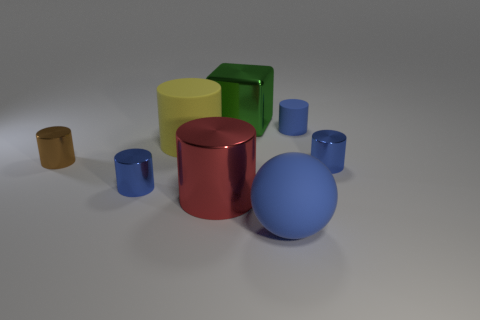How many blue cylinders must be subtracted to get 1 blue cylinders? 2 Subtract all big metal cylinders. How many cylinders are left? 5 Add 1 big objects. How many objects exist? 9 Subtract all cylinders. How many objects are left? 2 Subtract 1 blocks. How many blocks are left? 0 Subtract all blue cylinders. Subtract all blue blocks. How many cylinders are left? 3 Subtract all brown cylinders. How many yellow spheres are left? 0 Subtract all large green cubes. Subtract all small green things. How many objects are left? 7 Add 5 small blue things. How many small blue things are left? 8 Add 3 rubber spheres. How many rubber spheres exist? 4 